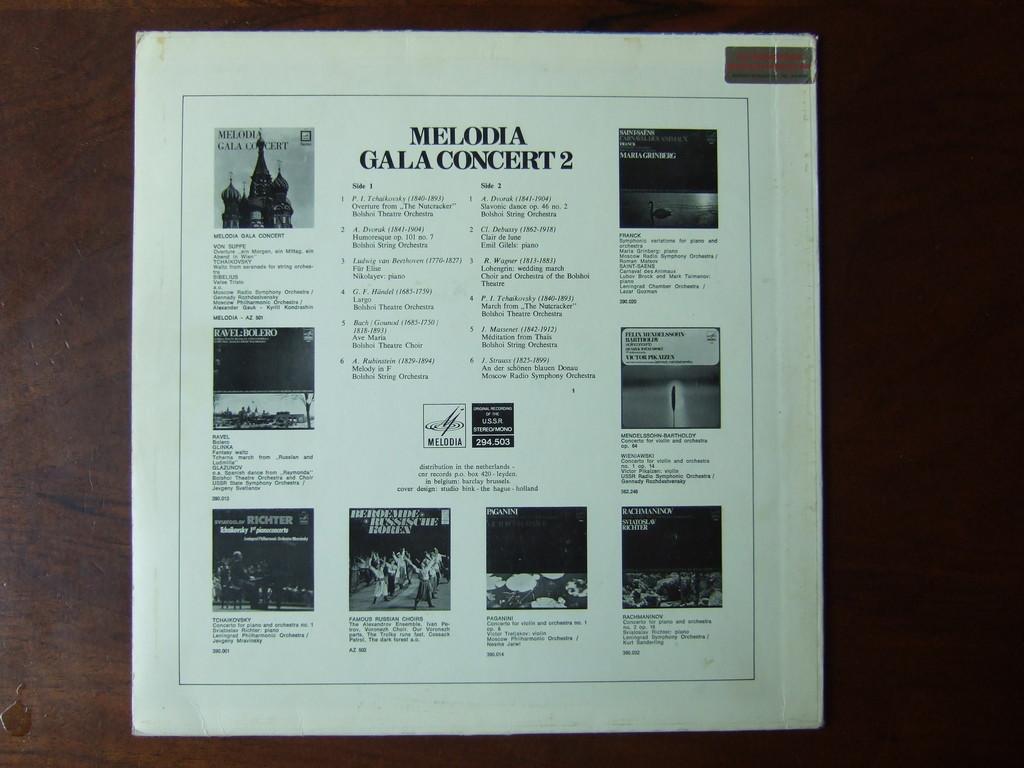What's the title of this page?
Offer a terse response. Melodia gala concert 2. What concert is it?
Your answer should be very brief. Melodia gala. 